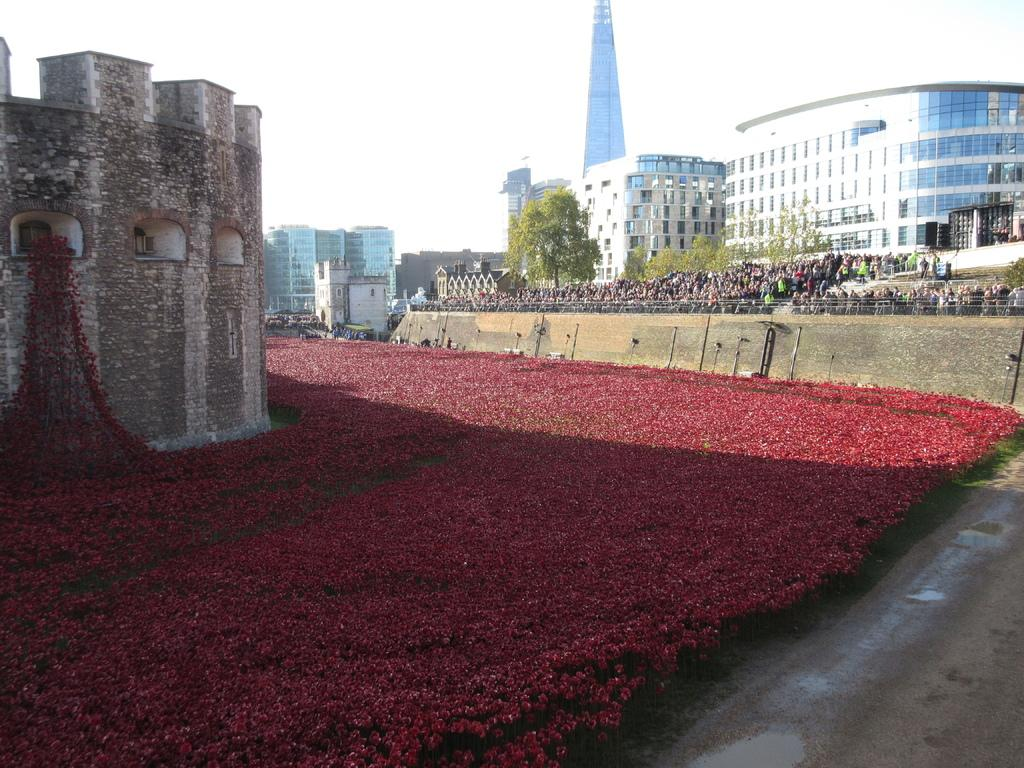What type of plants can be seen in the image? There are flowers in the image. What structure is located on the left side of the image? There is a building on the left side of the image. What can be seen in the background of the image? There are people, trees, and buildings visible in the background of the image. What type of pear is being used as a prop in the image? There is no pear present in the image. What act are the people in the background performing? The image does not show any specific act being performed by the people in the background. 